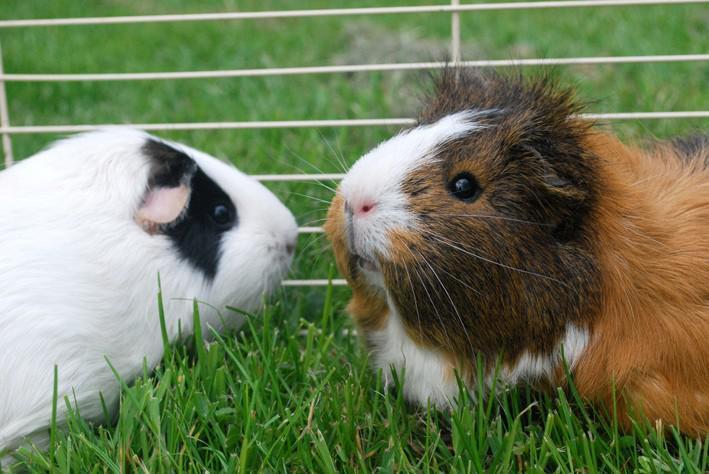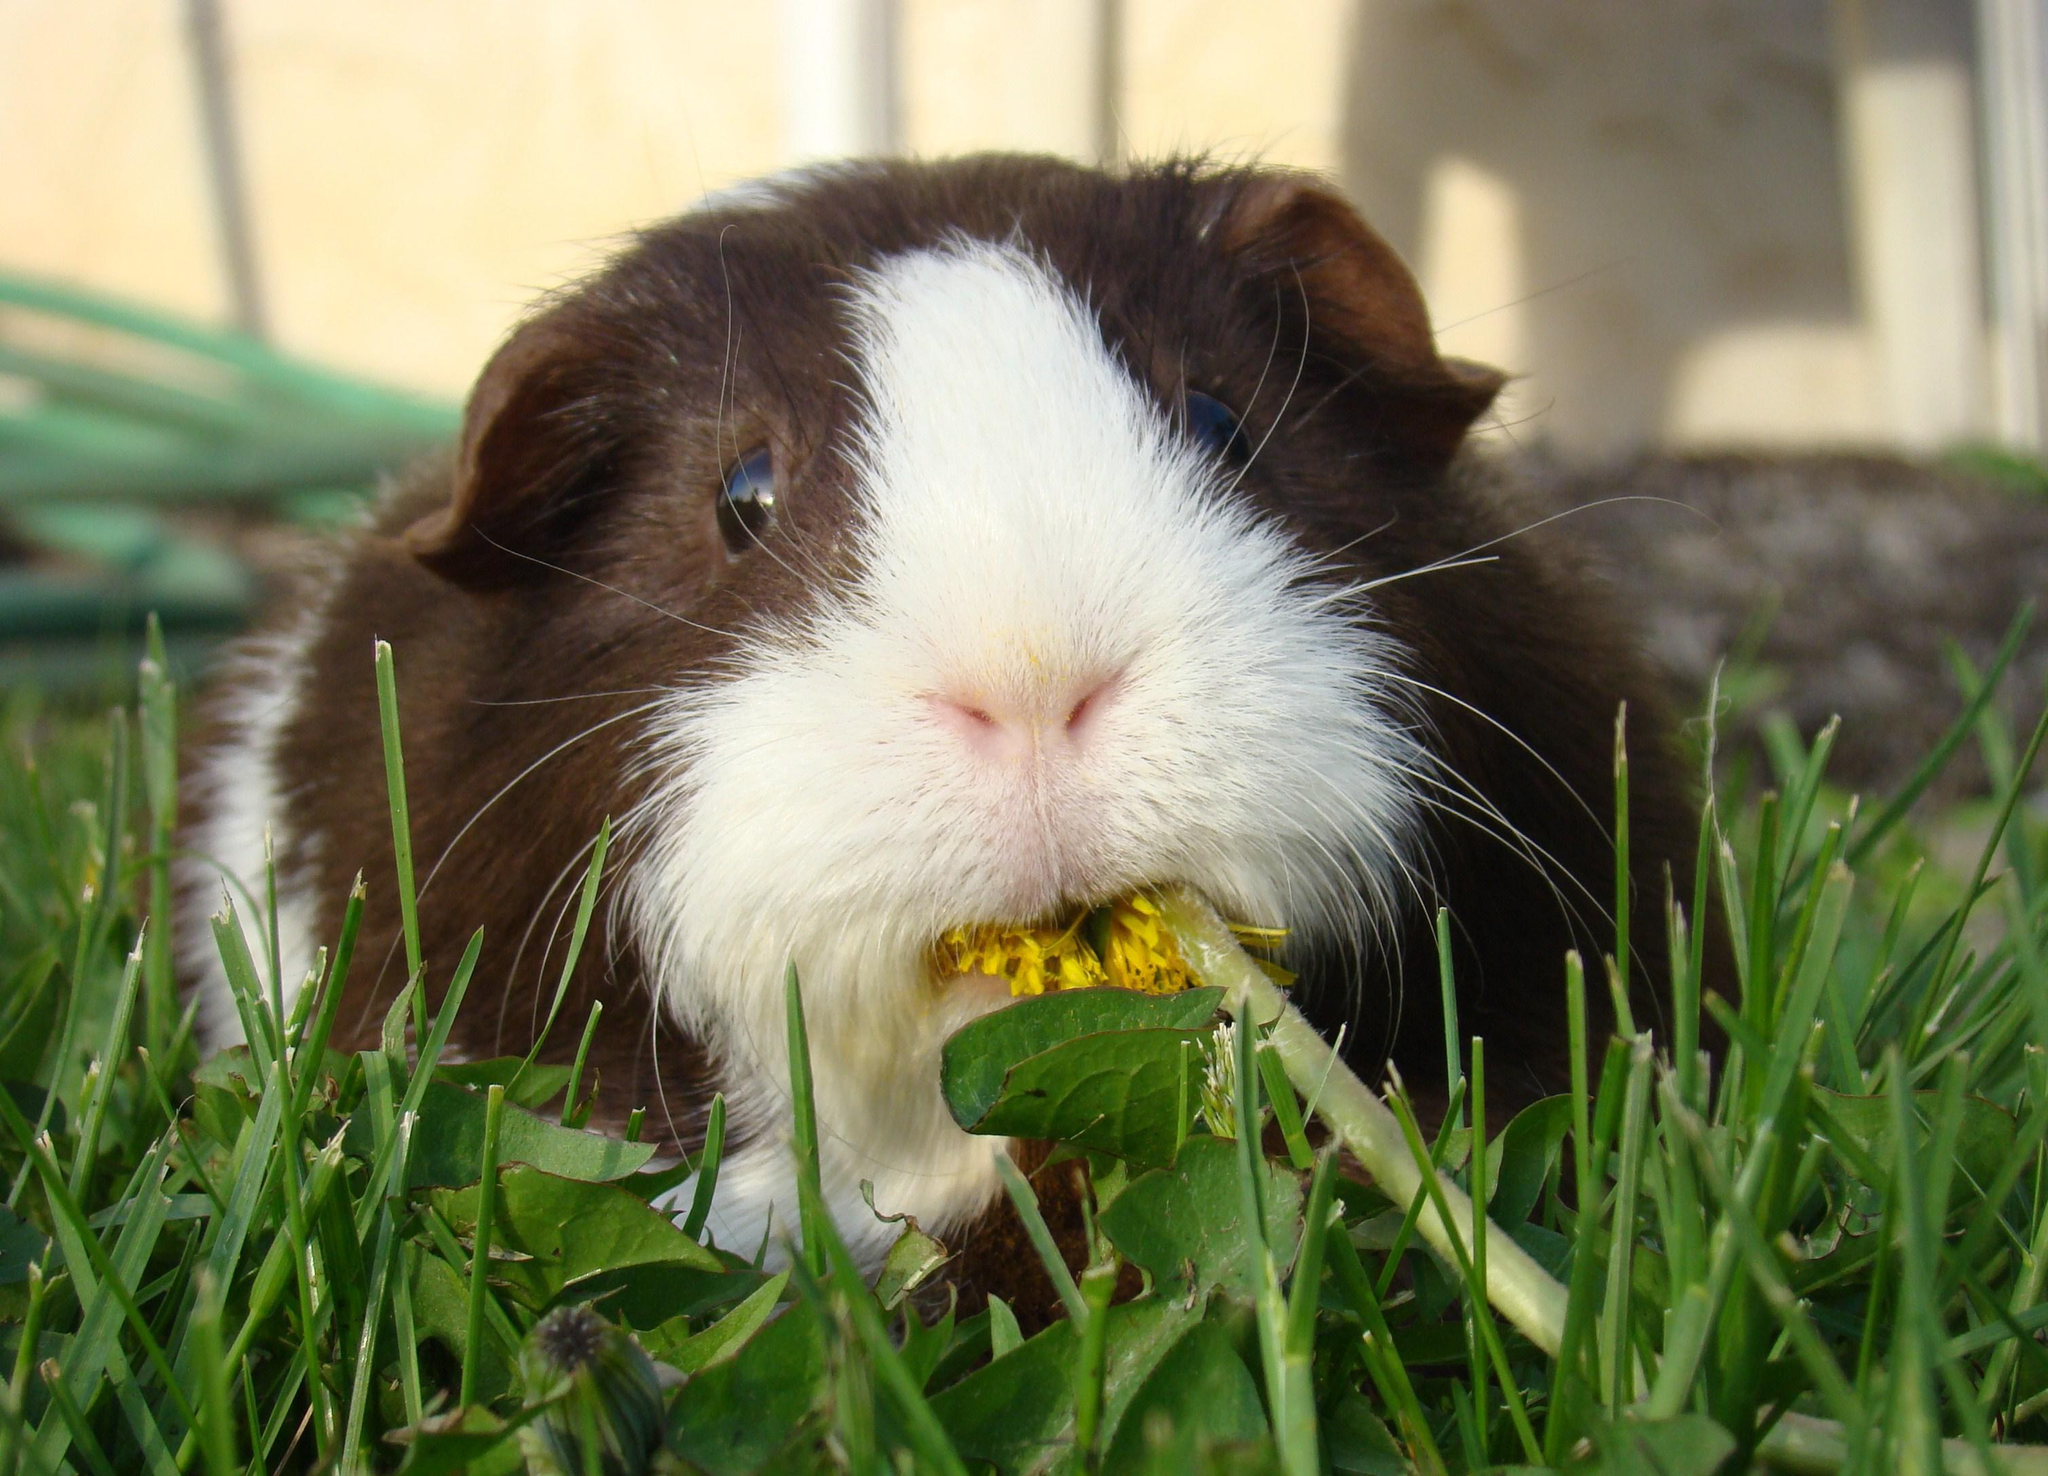The first image is the image on the left, the second image is the image on the right. Considering the images on both sides, is "One little animal is wearing a bunch of yellow and white daisies on its head." valid? Answer yes or no. No. 